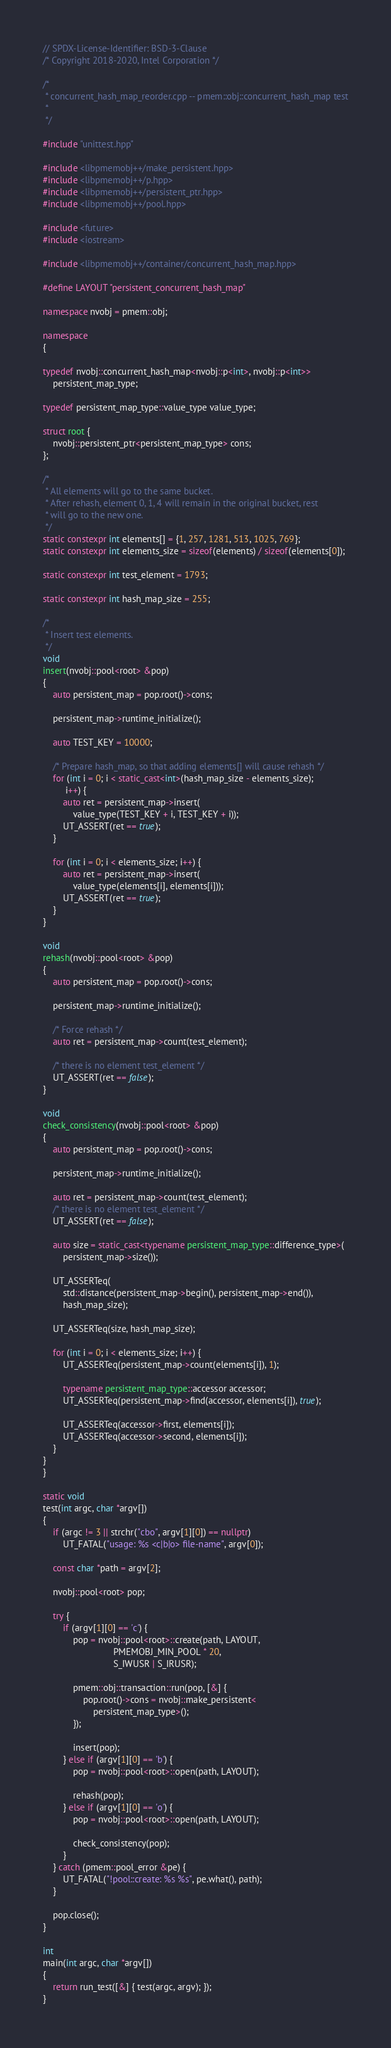<code> <loc_0><loc_0><loc_500><loc_500><_C++_>// SPDX-License-Identifier: BSD-3-Clause
/* Copyright 2018-2020, Intel Corporation */

/*
 * concurrent_hash_map_reorder.cpp -- pmem::obj::concurrent_hash_map test
 *
 */

#include "unittest.hpp"

#include <libpmemobj++/make_persistent.hpp>
#include <libpmemobj++/p.hpp>
#include <libpmemobj++/persistent_ptr.hpp>
#include <libpmemobj++/pool.hpp>

#include <future>
#include <iostream>

#include <libpmemobj++/container/concurrent_hash_map.hpp>

#define LAYOUT "persistent_concurrent_hash_map"

namespace nvobj = pmem::obj;

namespace
{

typedef nvobj::concurrent_hash_map<nvobj::p<int>, nvobj::p<int>>
	persistent_map_type;

typedef persistent_map_type::value_type value_type;

struct root {
	nvobj::persistent_ptr<persistent_map_type> cons;
};

/*
 * All elements will go to the same bucket.
 * After rehash, element 0, 1, 4 will remain in the original bucket, rest
 * will go to the new one.
 */
static constexpr int elements[] = {1, 257, 1281, 513, 1025, 769};
static constexpr int elements_size = sizeof(elements) / sizeof(elements[0]);

static constexpr int test_element = 1793;

static constexpr int hash_map_size = 255;

/*
 * Insert test elements.
 */
void
insert(nvobj::pool<root> &pop)
{
	auto persistent_map = pop.root()->cons;

	persistent_map->runtime_initialize();

	auto TEST_KEY = 10000;

	/* Prepare hash_map, so that adding elements[] will cause rehash */
	for (int i = 0; i < static_cast<int>(hash_map_size - elements_size);
	     i++) {
		auto ret = persistent_map->insert(
			value_type(TEST_KEY + i, TEST_KEY + i));
		UT_ASSERT(ret == true);
	}

	for (int i = 0; i < elements_size; i++) {
		auto ret = persistent_map->insert(
			value_type(elements[i], elements[i]));
		UT_ASSERT(ret == true);
	}
}

void
rehash(nvobj::pool<root> &pop)
{
	auto persistent_map = pop.root()->cons;

	persistent_map->runtime_initialize();

	/* Force rehash */
	auto ret = persistent_map->count(test_element);

	/* there is no element test_element */
	UT_ASSERT(ret == false);
}

void
check_consistency(nvobj::pool<root> &pop)
{
	auto persistent_map = pop.root()->cons;

	persistent_map->runtime_initialize();

	auto ret = persistent_map->count(test_element);
	/* there is no element test_element */
	UT_ASSERT(ret == false);

	auto size = static_cast<typename persistent_map_type::difference_type>(
		persistent_map->size());

	UT_ASSERTeq(
		std::distance(persistent_map->begin(), persistent_map->end()),
		hash_map_size);

	UT_ASSERTeq(size, hash_map_size);

	for (int i = 0; i < elements_size; i++) {
		UT_ASSERTeq(persistent_map->count(elements[i]), 1);

		typename persistent_map_type::accessor accessor;
		UT_ASSERTeq(persistent_map->find(accessor, elements[i]), true);

		UT_ASSERTeq(accessor->first, elements[i]);
		UT_ASSERTeq(accessor->second, elements[i]);
	}
}
}

static void
test(int argc, char *argv[])
{
	if (argc != 3 || strchr("cbo", argv[1][0]) == nullptr)
		UT_FATAL("usage: %s <c|b|o> file-name", argv[0]);

	const char *path = argv[2];

	nvobj::pool<root> pop;

	try {
		if (argv[1][0] == 'c') {
			pop = nvobj::pool<root>::create(path, LAYOUT,
							PMEMOBJ_MIN_POOL * 20,
							S_IWUSR | S_IRUSR);

			pmem::obj::transaction::run(pop, [&] {
				pop.root()->cons = nvobj::make_persistent<
					persistent_map_type>();
			});

			insert(pop);
		} else if (argv[1][0] == 'b') {
			pop = nvobj::pool<root>::open(path, LAYOUT);

			rehash(pop);
		} else if (argv[1][0] == 'o') {
			pop = nvobj::pool<root>::open(path, LAYOUT);

			check_consistency(pop);
		}
	} catch (pmem::pool_error &pe) {
		UT_FATAL("!pool::create: %s %s", pe.what(), path);
	}

	pop.close();
}

int
main(int argc, char *argv[])
{
	return run_test([&] { test(argc, argv); });
}
</code> 